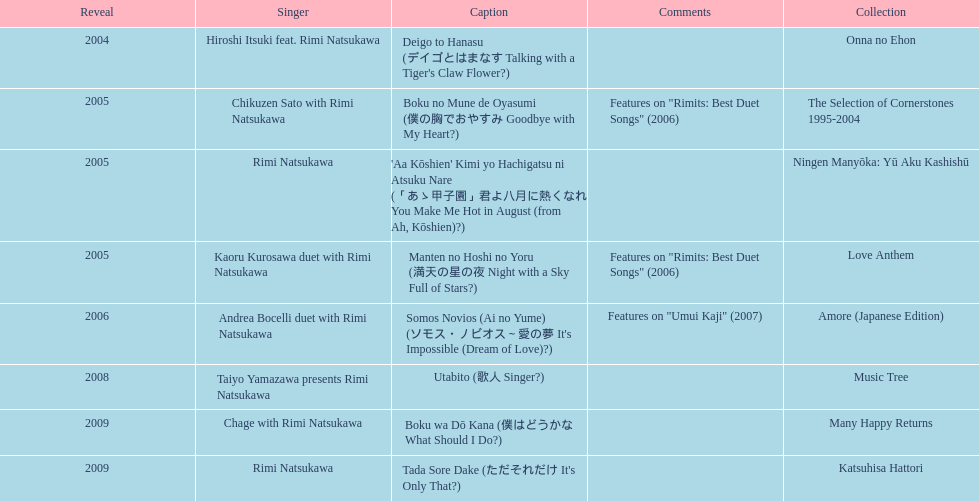In which year was the initial title launched? 2004. 